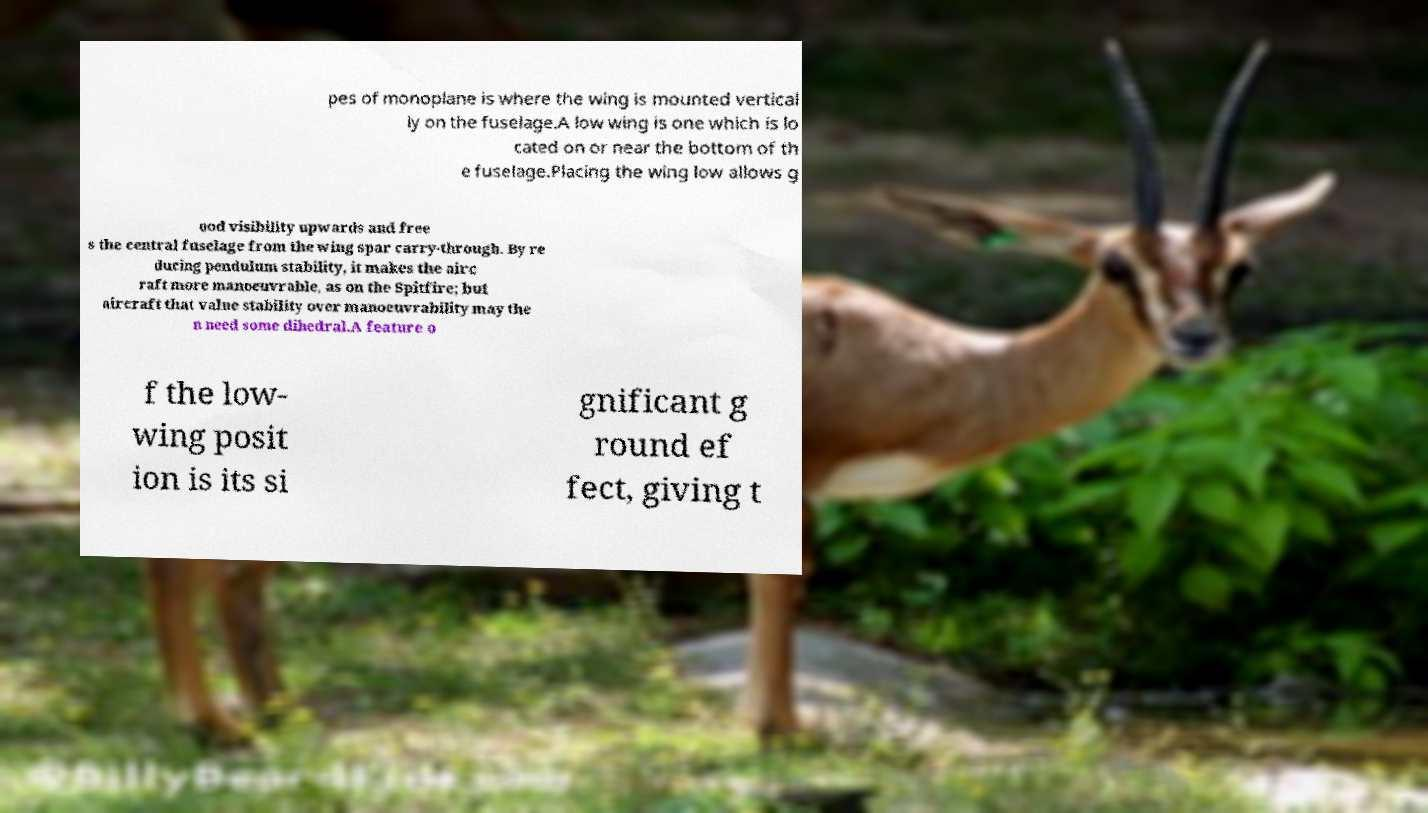Can you accurately transcribe the text from the provided image for me? pes of monoplane is where the wing is mounted vertical ly on the fuselage.A low wing is one which is lo cated on or near the bottom of th e fuselage.Placing the wing low allows g ood visibility upwards and free s the central fuselage from the wing spar carry-through. By re ducing pendulum stability, it makes the airc raft more manoeuvrable, as on the Spitfire; but aircraft that value stability over manoeuvrability may the n need some dihedral.A feature o f the low- wing posit ion is its si gnificant g round ef fect, giving t 